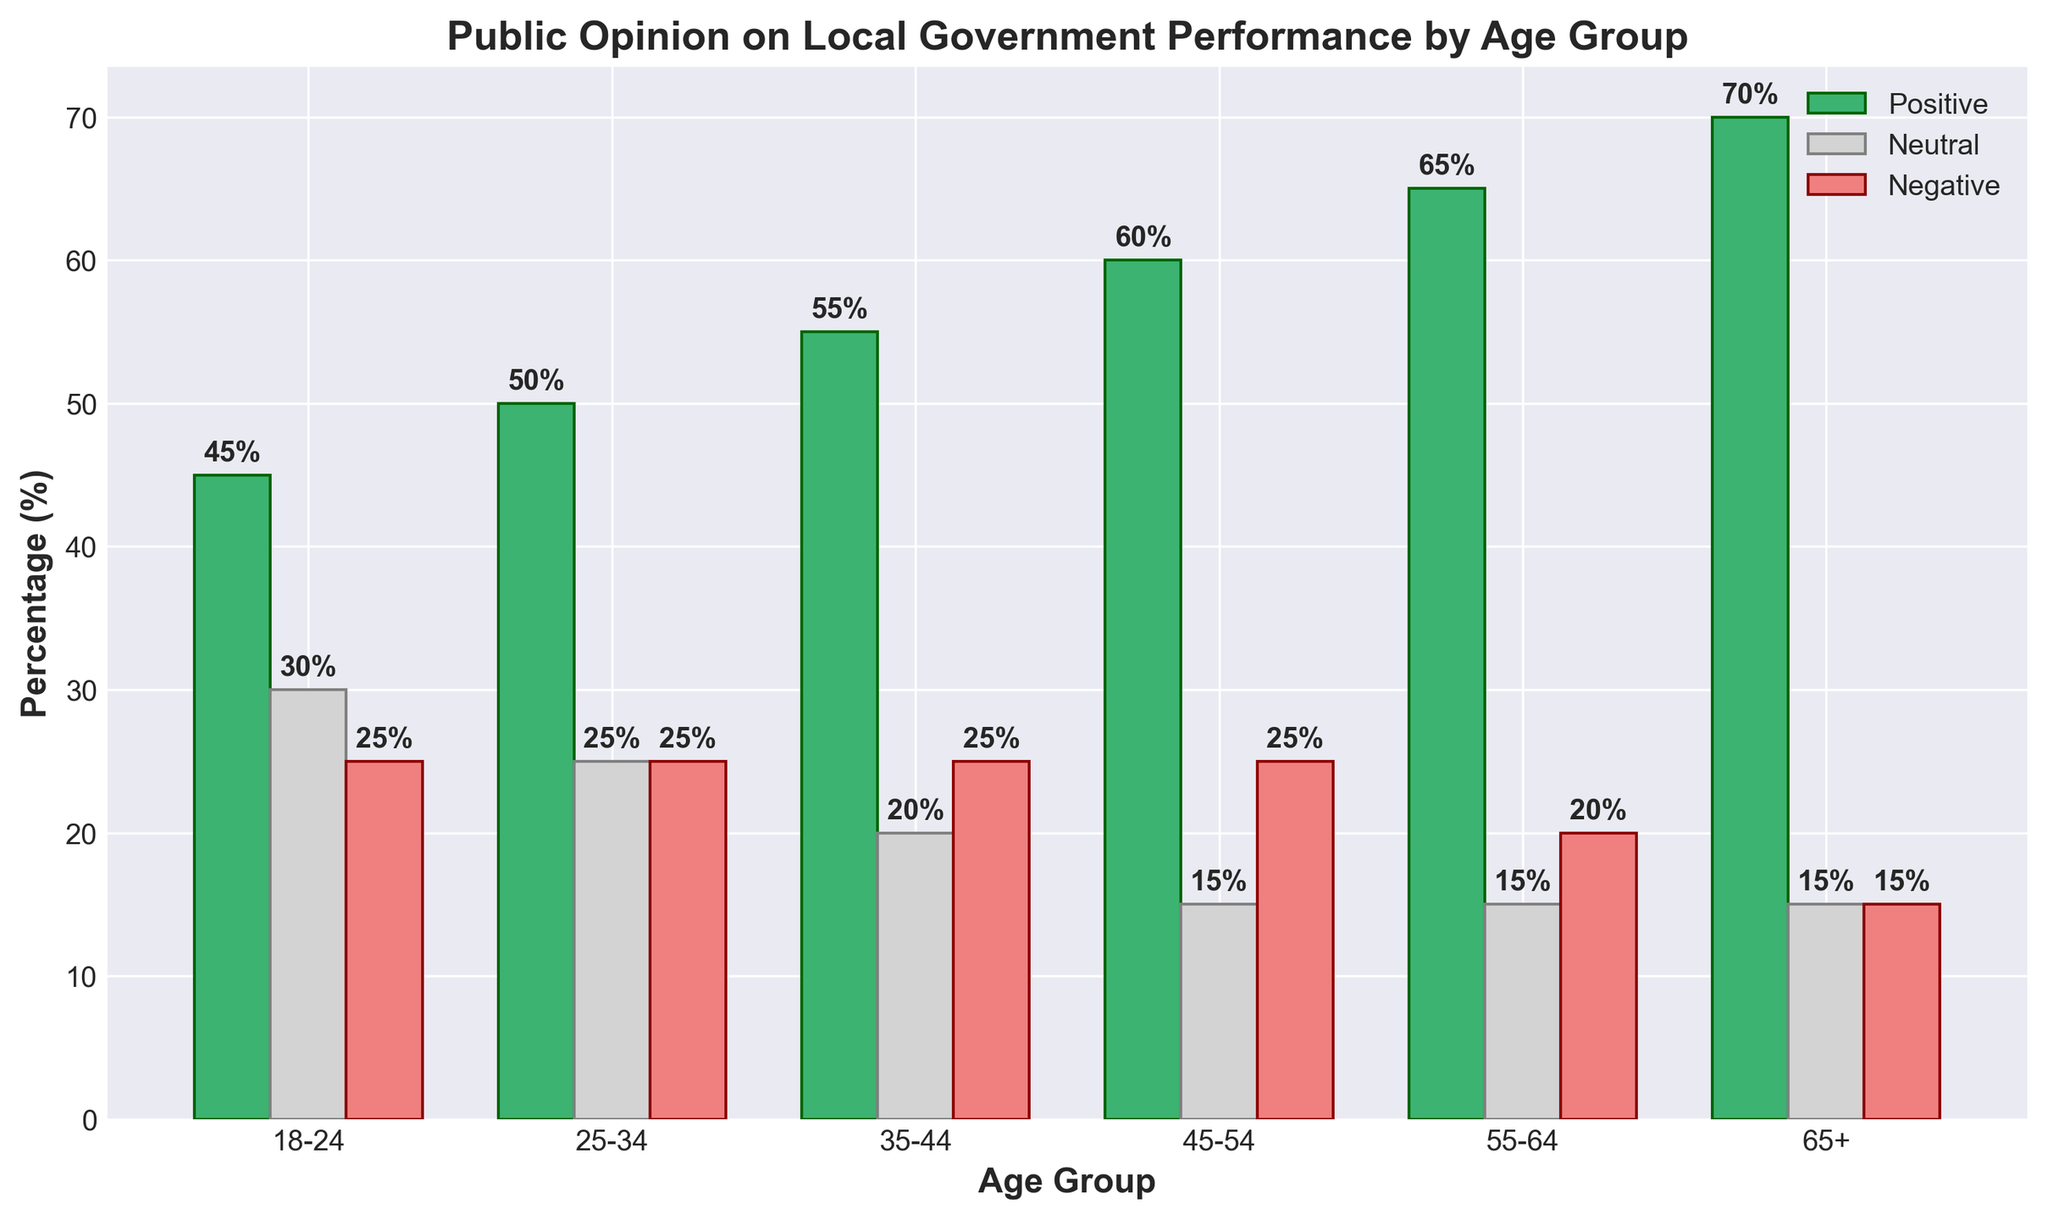What age group has the highest percentage of positive opinions on local government performance? The bar representing the 65+ age group has the tallest height in the 'Positive' category, indicating the highest percentage.
Answer: 65+ Which age group has the smallest difference between positive and negative opinions? The 'Negative' and 'Positive' bars for the 18-24 age group have the closest heights, with a difference of 45% - 25% = 20%.
Answer: 18-24 What is the total percentage of neutral opinions across all age groups? Summing up the 'Neutral' percentages: 30 + 25 + 20 + 15 + 15 + 15 = 120%.
Answer: 120% Which age group has more negative opinions than neutral opinions? For the 18-24 age group, the 'Negative' bar is at 25%, and the 'Neutral' bar is at 30%. For all other groups, the 'Neutral' and 'Negative' bars are equal or have 'Neutral' higher than 'Negative.' Hence, no group has more 'Negative' opinions than 'Neutral' ones.
Answer: None In which age group is the proportion of positive opinions more than twice the proportion of negative opinions? Considering the 'Positive' and 'Negative' bars for each age group:
- 18-24: 45% not > 2*25%
- 25-34: 50% not > 2*25%
- 35-44: 55% not > 2*25%
- 45-54: 60% not > 2*25%
- 55-64: 65% > 2*20%
- 65+: 70% > 2*15% 
Therefore, the 55-64 and 65+ age groups meet this condition.
Answer: 55-64 and 65+ What is the combined percentage of people aged 45-54 who have neutral and negative opinions? Adding the 'Neutral' and 'Negative' percentages for 45-54 age group: 15% + 25% = 40%.
Answer: 40% By how much does the positive opinion of the 25-34 age group exceed the neutral opinion of the same group? The difference between the 'Positive' and 'Neutral' bars for the 25-34 age group is 50% - 25% = 25%.
Answer: 25% Which age group has the least negative opinion percentage? The 'Negative' bar for the 65+ age group is the shortest, representing the smallest percentage place it at 15%.
Answer: 65+ What is the average percentage of positive opinions across all age groups? Summing all 'Positive' percentages and dividing by the number of age groups (45 + 50 + 55 + 60 + 65 + 70) / 6 results in (345 / 6) ≈ 57.5%.
Answer: 57.5% Does any age group have an equal percentage of neutral and negative opinions? The 'Neutral' and 'Negative' bars are both at 25% for the 18-24 and 25-34 age groups.
Answer: 18-24 and 25-34 